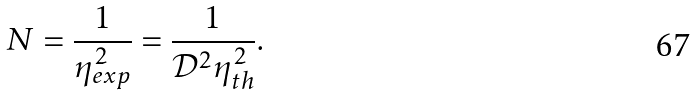Convert formula to latex. <formula><loc_0><loc_0><loc_500><loc_500>N = \frac { 1 } { \eta _ { e x p } ^ { 2 } } = \frac { 1 } { \mathcal { D } ^ { 2 } \eta _ { t h } ^ { 2 } } .</formula> 